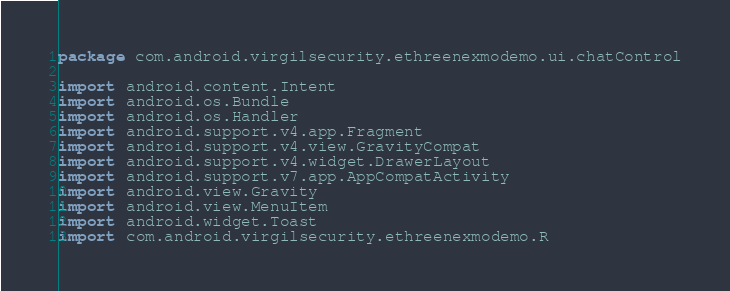<code> <loc_0><loc_0><loc_500><loc_500><_Kotlin_>package com.android.virgilsecurity.ethreenexmodemo.ui.chatControl

import android.content.Intent
import android.os.Bundle
import android.os.Handler
import android.support.v4.app.Fragment
import android.support.v4.view.GravityCompat
import android.support.v4.widget.DrawerLayout
import android.support.v7.app.AppCompatActivity
import android.view.Gravity
import android.view.MenuItem
import android.widget.Toast
import com.android.virgilsecurity.ethreenexmodemo.R</code> 